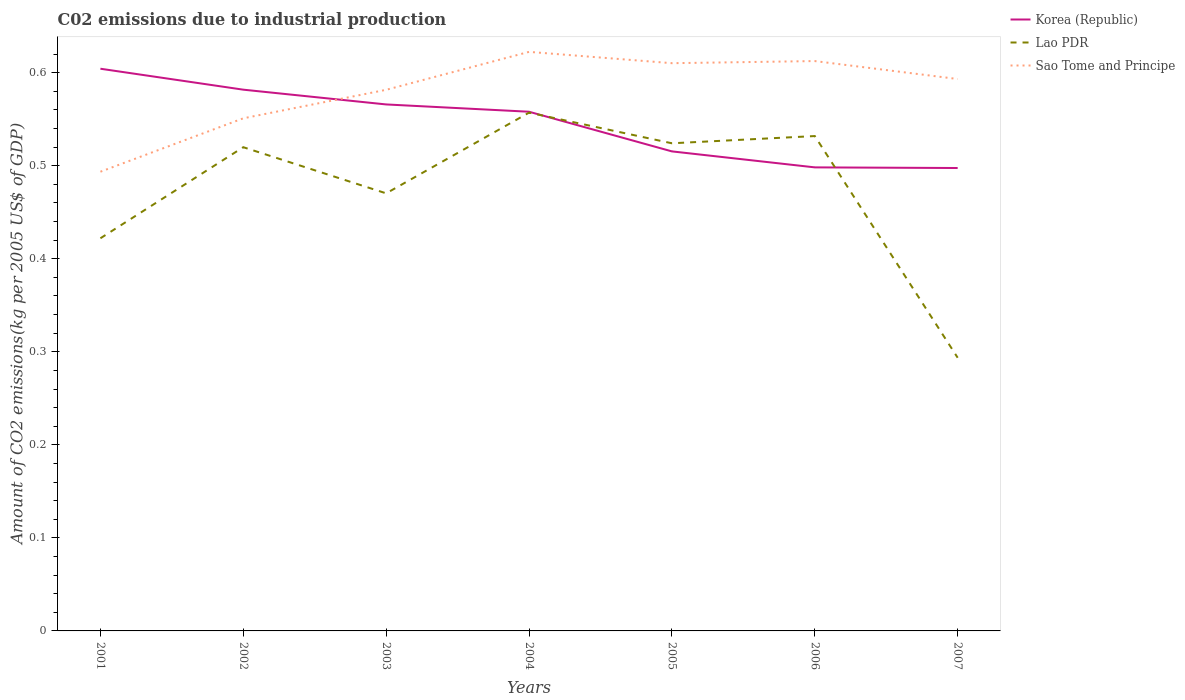Does the line corresponding to Korea (Republic) intersect with the line corresponding to Sao Tome and Principe?
Your response must be concise. Yes. Is the number of lines equal to the number of legend labels?
Keep it short and to the point. Yes. Across all years, what is the maximum amount of CO2 emitted due to industrial production in Sao Tome and Principe?
Keep it short and to the point. 0.49. What is the total amount of CO2 emitted due to industrial production in Korea (Republic) in the graph?
Provide a succinct answer. 0.07. What is the difference between the highest and the second highest amount of CO2 emitted due to industrial production in Korea (Republic)?
Your answer should be compact. 0.11. What is the difference between the highest and the lowest amount of CO2 emitted due to industrial production in Sao Tome and Principe?
Your answer should be compact. 5. Is the amount of CO2 emitted due to industrial production in Korea (Republic) strictly greater than the amount of CO2 emitted due to industrial production in Lao PDR over the years?
Keep it short and to the point. No. How many lines are there?
Offer a very short reply. 3. How many years are there in the graph?
Offer a very short reply. 7. How are the legend labels stacked?
Provide a succinct answer. Vertical. What is the title of the graph?
Provide a succinct answer. C02 emissions due to industrial production. Does "Northern Mariana Islands" appear as one of the legend labels in the graph?
Offer a very short reply. No. What is the label or title of the Y-axis?
Provide a short and direct response. Amount of CO2 emissions(kg per 2005 US$ of GDP). What is the Amount of CO2 emissions(kg per 2005 US$ of GDP) in Korea (Republic) in 2001?
Provide a succinct answer. 0.6. What is the Amount of CO2 emissions(kg per 2005 US$ of GDP) in Lao PDR in 2001?
Your answer should be compact. 0.42. What is the Amount of CO2 emissions(kg per 2005 US$ of GDP) of Sao Tome and Principe in 2001?
Your answer should be compact. 0.49. What is the Amount of CO2 emissions(kg per 2005 US$ of GDP) of Korea (Republic) in 2002?
Keep it short and to the point. 0.58. What is the Amount of CO2 emissions(kg per 2005 US$ of GDP) of Lao PDR in 2002?
Your answer should be compact. 0.52. What is the Amount of CO2 emissions(kg per 2005 US$ of GDP) in Sao Tome and Principe in 2002?
Keep it short and to the point. 0.55. What is the Amount of CO2 emissions(kg per 2005 US$ of GDP) in Korea (Republic) in 2003?
Provide a succinct answer. 0.57. What is the Amount of CO2 emissions(kg per 2005 US$ of GDP) in Lao PDR in 2003?
Provide a short and direct response. 0.47. What is the Amount of CO2 emissions(kg per 2005 US$ of GDP) of Sao Tome and Principe in 2003?
Give a very brief answer. 0.58. What is the Amount of CO2 emissions(kg per 2005 US$ of GDP) of Korea (Republic) in 2004?
Your response must be concise. 0.56. What is the Amount of CO2 emissions(kg per 2005 US$ of GDP) in Lao PDR in 2004?
Your answer should be very brief. 0.56. What is the Amount of CO2 emissions(kg per 2005 US$ of GDP) of Sao Tome and Principe in 2004?
Provide a short and direct response. 0.62. What is the Amount of CO2 emissions(kg per 2005 US$ of GDP) of Korea (Republic) in 2005?
Your answer should be very brief. 0.52. What is the Amount of CO2 emissions(kg per 2005 US$ of GDP) of Lao PDR in 2005?
Ensure brevity in your answer.  0.52. What is the Amount of CO2 emissions(kg per 2005 US$ of GDP) in Sao Tome and Principe in 2005?
Your answer should be compact. 0.61. What is the Amount of CO2 emissions(kg per 2005 US$ of GDP) of Korea (Republic) in 2006?
Your answer should be very brief. 0.5. What is the Amount of CO2 emissions(kg per 2005 US$ of GDP) of Lao PDR in 2006?
Offer a very short reply. 0.53. What is the Amount of CO2 emissions(kg per 2005 US$ of GDP) in Sao Tome and Principe in 2006?
Keep it short and to the point. 0.61. What is the Amount of CO2 emissions(kg per 2005 US$ of GDP) of Korea (Republic) in 2007?
Provide a succinct answer. 0.5. What is the Amount of CO2 emissions(kg per 2005 US$ of GDP) in Lao PDR in 2007?
Offer a terse response. 0.29. What is the Amount of CO2 emissions(kg per 2005 US$ of GDP) of Sao Tome and Principe in 2007?
Your answer should be compact. 0.59. Across all years, what is the maximum Amount of CO2 emissions(kg per 2005 US$ of GDP) in Korea (Republic)?
Offer a terse response. 0.6. Across all years, what is the maximum Amount of CO2 emissions(kg per 2005 US$ of GDP) in Lao PDR?
Offer a terse response. 0.56. Across all years, what is the maximum Amount of CO2 emissions(kg per 2005 US$ of GDP) in Sao Tome and Principe?
Your answer should be very brief. 0.62. Across all years, what is the minimum Amount of CO2 emissions(kg per 2005 US$ of GDP) in Korea (Republic)?
Provide a succinct answer. 0.5. Across all years, what is the minimum Amount of CO2 emissions(kg per 2005 US$ of GDP) in Lao PDR?
Give a very brief answer. 0.29. Across all years, what is the minimum Amount of CO2 emissions(kg per 2005 US$ of GDP) in Sao Tome and Principe?
Your answer should be compact. 0.49. What is the total Amount of CO2 emissions(kg per 2005 US$ of GDP) in Korea (Republic) in the graph?
Keep it short and to the point. 3.82. What is the total Amount of CO2 emissions(kg per 2005 US$ of GDP) in Lao PDR in the graph?
Keep it short and to the point. 3.32. What is the total Amount of CO2 emissions(kg per 2005 US$ of GDP) in Sao Tome and Principe in the graph?
Give a very brief answer. 4.06. What is the difference between the Amount of CO2 emissions(kg per 2005 US$ of GDP) of Korea (Republic) in 2001 and that in 2002?
Your answer should be compact. 0.02. What is the difference between the Amount of CO2 emissions(kg per 2005 US$ of GDP) in Lao PDR in 2001 and that in 2002?
Your answer should be compact. -0.1. What is the difference between the Amount of CO2 emissions(kg per 2005 US$ of GDP) in Sao Tome and Principe in 2001 and that in 2002?
Keep it short and to the point. -0.06. What is the difference between the Amount of CO2 emissions(kg per 2005 US$ of GDP) of Korea (Republic) in 2001 and that in 2003?
Your answer should be compact. 0.04. What is the difference between the Amount of CO2 emissions(kg per 2005 US$ of GDP) in Lao PDR in 2001 and that in 2003?
Provide a short and direct response. -0.05. What is the difference between the Amount of CO2 emissions(kg per 2005 US$ of GDP) of Sao Tome and Principe in 2001 and that in 2003?
Give a very brief answer. -0.09. What is the difference between the Amount of CO2 emissions(kg per 2005 US$ of GDP) of Korea (Republic) in 2001 and that in 2004?
Make the answer very short. 0.05. What is the difference between the Amount of CO2 emissions(kg per 2005 US$ of GDP) of Lao PDR in 2001 and that in 2004?
Offer a terse response. -0.14. What is the difference between the Amount of CO2 emissions(kg per 2005 US$ of GDP) of Sao Tome and Principe in 2001 and that in 2004?
Offer a terse response. -0.13. What is the difference between the Amount of CO2 emissions(kg per 2005 US$ of GDP) of Korea (Republic) in 2001 and that in 2005?
Make the answer very short. 0.09. What is the difference between the Amount of CO2 emissions(kg per 2005 US$ of GDP) of Lao PDR in 2001 and that in 2005?
Provide a short and direct response. -0.1. What is the difference between the Amount of CO2 emissions(kg per 2005 US$ of GDP) of Sao Tome and Principe in 2001 and that in 2005?
Offer a very short reply. -0.12. What is the difference between the Amount of CO2 emissions(kg per 2005 US$ of GDP) in Korea (Republic) in 2001 and that in 2006?
Offer a very short reply. 0.11. What is the difference between the Amount of CO2 emissions(kg per 2005 US$ of GDP) in Lao PDR in 2001 and that in 2006?
Give a very brief answer. -0.11. What is the difference between the Amount of CO2 emissions(kg per 2005 US$ of GDP) of Sao Tome and Principe in 2001 and that in 2006?
Keep it short and to the point. -0.12. What is the difference between the Amount of CO2 emissions(kg per 2005 US$ of GDP) of Korea (Republic) in 2001 and that in 2007?
Keep it short and to the point. 0.11. What is the difference between the Amount of CO2 emissions(kg per 2005 US$ of GDP) of Lao PDR in 2001 and that in 2007?
Offer a terse response. 0.13. What is the difference between the Amount of CO2 emissions(kg per 2005 US$ of GDP) in Sao Tome and Principe in 2001 and that in 2007?
Give a very brief answer. -0.1. What is the difference between the Amount of CO2 emissions(kg per 2005 US$ of GDP) in Korea (Republic) in 2002 and that in 2003?
Your answer should be compact. 0.02. What is the difference between the Amount of CO2 emissions(kg per 2005 US$ of GDP) in Lao PDR in 2002 and that in 2003?
Offer a terse response. 0.05. What is the difference between the Amount of CO2 emissions(kg per 2005 US$ of GDP) in Sao Tome and Principe in 2002 and that in 2003?
Ensure brevity in your answer.  -0.03. What is the difference between the Amount of CO2 emissions(kg per 2005 US$ of GDP) in Korea (Republic) in 2002 and that in 2004?
Your answer should be very brief. 0.02. What is the difference between the Amount of CO2 emissions(kg per 2005 US$ of GDP) in Lao PDR in 2002 and that in 2004?
Your response must be concise. -0.04. What is the difference between the Amount of CO2 emissions(kg per 2005 US$ of GDP) of Sao Tome and Principe in 2002 and that in 2004?
Your answer should be compact. -0.07. What is the difference between the Amount of CO2 emissions(kg per 2005 US$ of GDP) of Korea (Republic) in 2002 and that in 2005?
Ensure brevity in your answer.  0.07. What is the difference between the Amount of CO2 emissions(kg per 2005 US$ of GDP) of Lao PDR in 2002 and that in 2005?
Keep it short and to the point. -0. What is the difference between the Amount of CO2 emissions(kg per 2005 US$ of GDP) of Sao Tome and Principe in 2002 and that in 2005?
Provide a short and direct response. -0.06. What is the difference between the Amount of CO2 emissions(kg per 2005 US$ of GDP) of Korea (Republic) in 2002 and that in 2006?
Offer a very short reply. 0.08. What is the difference between the Amount of CO2 emissions(kg per 2005 US$ of GDP) of Lao PDR in 2002 and that in 2006?
Your answer should be compact. -0.01. What is the difference between the Amount of CO2 emissions(kg per 2005 US$ of GDP) in Sao Tome and Principe in 2002 and that in 2006?
Give a very brief answer. -0.06. What is the difference between the Amount of CO2 emissions(kg per 2005 US$ of GDP) in Korea (Republic) in 2002 and that in 2007?
Provide a short and direct response. 0.08. What is the difference between the Amount of CO2 emissions(kg per 2005 US$ of GDP) in Lao PDR in 2002 and that in 2007?
Provide a succinct answer. 0.23. What is the difference between the Amount of CO2 emissions(kg per 2005 US$ of GDP) in Sao Tome and Principe in 2002 and that in 2007?
Keep it short and to the point. -0.04. What is the difference between the Amount of CO2 emissions(kg per 2005 US$ of GDP) in Korea (Republic) in 2003 and that in 2004?
Provide a succinct answer. 0.01. What is the difference between the Amount of CO2 emissions(kg per 2005 US$ of GDP) in Lao PDR in 2003 and that in 2004?
Your answer should be very brief. -0.09. What is the difference between the Amount of CO2 emissions(kg per 2005 US$ of GDP) of Sao Tome and Principe in 2003 and that in 2004?
Offer a very short reply. -0.04. What is the difference between the Amount of CO2 emissions(kg per 2005 US$ of GDP) in Korea (Republic) in 2003 and that in 2005?
Your answer should be very brief. 0.05. What is the difference between the Amount of CO2 emissions(kg per 2005 US$ of GDP) of Lao PDR in 2003 and that in 2005?
Give a very brief answer. -0.05. What is the difference between the Amount of CO2 emissions(kg per 2005 US$ of GDP) of Sao Tome and Principe in 2003 and that in 2005?
Provide a short and direct response. -0.03. What is the difference between the Amount of CO2 emissions(kg per 2005 US$ of GDP) of Korea (Republic) in 2003 and that in 2006?
Ensure brevity in your answer.  0.07. What is the difference between the Amount of CO2 emissions(kg per 2005 US$ of GDP) of Lao PDR in 2003 and that in 2006?
Keep it short and to the point. -0.06. What is the difference between the Amount of CO2 emissions(kg per 2005 US$ of GDP) of Sao Tome and Principe in 2003 and that in 2006?
Keep it short and to the point. -0.03. What is the difference between the Amount of CO2 emissions(kg per 2005 US$ of GDP) in Korea (Republic) in 2003 and that in 2007?
Provide a short and direct response. 0.07. What is the difference between the Amount of CO2 emissions(kg per 2005 US$ of GDP) in Lao PDR in 2003 and that in 2007?
Offer a very short reply. 0.18. What is the difference between the Amount of CO2 emissions(kg per 2005 US$ of GDP) in Sao Tome and Principe in 2003 and that in 2007?
Give a very brief answer. -0.01. What is the difference between the Amount of CO2 emissions(kg per 2005 US$ of GDP) in Korea (Republic) in 2004 and that in 2005?
Your response must be concise. 0.04. What is the difference between the Amount of CO2 emissions(kg per 2005 US$ of GDP) of Lao PDR in 2004 and that in 2005?
Ensure brevity in your answer.  0.03. What is the difference between the Amount of CO2 emissions(kg per 2005 US$ of GDP) of Sao Tome and Principe in 2004 and that in 2005?
Give a very brief answer. 0.01. What is the difference between the Amount of CO2 emissions(kg per 2005 US$ of GDP) of Korea (Republic) in 2004 and that in 2006?
Offer a terse response. 0.06. What is the difference between the Amount of CO2 emissions(kg per 2005 US$ of GDP) of Lao PDR in 2004 and that in 2006?
Your answer should be very brief. 0.03. What is the difference between the Amount of CO2 emissions(kg per 2005 US$ of GDP) in Sao Tome and Principe in 2004 and that in 2006?
Offer a terse response. 0.01. What is the difference between the Amount of CO2 emissions(kg per 2005 US$ of GDP) of Korea (Republic) in 2004 and that in 2007?
Provide a short and direct response. 0.06. What is the difference between the Amount of CO2 emissions(kg per 2005 US$ of GDP) in Lao PDR in 2004 and that in 2007?
Offer a very short reply. 0.26. What is the difference between the Amount of CO2 emissions(kg per 2005 US$ of GDP) in Sao Tome and Principe in 2004 and that in 2007?
Keep it short and to the point. 0.03. What is the difference between the Amount of CO2 emissions(kg per 2005 US$ of GDP) of Korea (Republic) in 2005 and that in 2006?
Make the answer very short. 0.02. What is the difference between the Amount of CO2 emissions(kg per 2005 US$ of GDP) of Lao PDR in 2005 and that in 2006?
Your response must be concise. -0.01. What is the difference between the Amount of CO2 emissions(kg per 2005 US$ of GDP) in Sao Tome and Principe in 2005 and that in 2006?
Make the answer very short. -0. What is the difference between the Amount of CO2 emissions(kg per 2005 US$ of GDP) in Korea (Republic) in 2005 and that in 2007?
Ensure brevity in your answer.  0.02. What is the difference between the Amount of CO2 emissions(kg per 2005 US$ of GDP) in Lao PDR in 2005 and that in 2007?
Offer a very short reply. 0.23. What is the difference between the Amount of CO2 emissions(kg per 2005 US$ of GDP) in Sao Tome and Principe in 2005 and that in 2007?
Your answer should be very brief. 0.02. What is the difference between the Amount of CO2 emissions(kg per 2005 US$ of GDP) in Korea (Republic) in 2006 and that in 2007?
Your answer should be very brief. 0. What is the difference between the Amount of CO2 emissions(kg per 2005 US$ of GDP) in Lao PDR in 2006 and that in 2007?
Your response must be concise. 0.24. What is the difference between the Amount of CO2 emissions(kg per 2005 US$ of GDP) of Sao Tome and Principe in 2006 and that in 2007?
Your response must be concise. 0.02. What is the difference between the Amount of CO2 emissions(kg per 2005 US$ of GDP) of Korea (Republic) in 2001 and the Amount of CO2 emissions(kg per 2005 US$ of GDP) of Lao PDR in 2002?
Make the answer very short. 0.08. What is the difference between the Amount of CO2 emissions(kg per 2005 US$ of GDP) of Korea (Republic) in 2001 and the Amount of CO2 emissions(kg per 2005 US$ of GDP) of Sao Tome and Principe in 2002?
Ensure brevity in your answer.  0.05. What is the difference between the Amount of CO2 emissions(kg per 2005 US$ of GDP) in Lao PDR in 2001 and the Amount of CO2 emissions(kg per 2005 US$ of GDP) in Sao Tome and Principe in 2002?
Provide a short and direct response. -0.13. What is the difference between the Amount of CO2 emissions(kg per 2005 US$ of GDP) of Korea (Republic) in 2001 and the Amount of CO2 emissions(kg per 2005 US$ of GDP) of Lao PDR in 2003?
Provide a succinct answer. 0.13. What is the difference between the Amount of CO2 emissions(kg per 2005 US$ of GDP) of Korea (Republic) in 2001 and the Amount of CO2 emissions(kg per 2005 US$ of GDP) of Sao Tome and Principe in 2003?
Your answer should be very brief. 0.02. What is the difference between the Amount of CO2 emissions(kg per 2005 US$ of GDP) in Lao PDR in 2001 and the Amount of CO2 emissions(kg per 2005 US$ of GDP) in Sao Tome and Principe in 2003?
Give a very brief answer. -0.16. What is the difference between the Amount of CO2 emissions(kg per 2005 US$ of GDP) in Korea (Republic) in 2001 and the Amount of CO2 emissions(kg per 2005 US$ of GDP) in Lao PDR in 2004?
Give a very brief answer. 0.05. What is the difference between the Amount of CO2 emissions(kg per 2005 US$ of GDP) in Korea (Republic) in 2001 and the Amount of CO2 emissions(kg per 2005 US$ of GDP) in Sao Tome and Principe in 2004?
Your response must be concise. -0.02. What is the difference between the Amount of CO2 emissions(kg per 2005 US$ of GDP) of Lao PDR in 2001 and the Amount of CO2 emissions(kg per 2005 US$ of GDP) of Sao Tome and Principe in 2004?
Your answer should be very brief. -0.2. What is the difference between the Amount of CO2 emissions(kg per 2005 US$ of GDP) of Korea (Republic) in 2001 and the Amount of CO2 emissions(kg per 2005 US$ of GDP) of Lao PDR in 2005?
Your response must be concise. 0.08. What is the difference between the Amount of CO2 emissions(kg per 2005 US$ of GDP) in Korea (Republic) in 2001 and the Amount of CO2 emissions(kg per 2005 US$ of GDP) in Sao Tome and Principe in 2005?
Keep it short and to the point. -0.01. What is the difference between the Amount of CO2 emissions(kg per 2005 US$ of GDP) in Lao PDR in 2001 and the Amount of CO2 emissions(kg per 2005 US$ of GDP) in Sao Tome and Principe in 2005?
Give a very brief answer. -0.19. What is the difference between the Amount of CO2 emissions(kg per 2005 US$ of GDP) of Korea (Republic) in 2001 and the Amount of CO2 emissions(kg per 2005 US$ of GDP) of Lao PDR in 2006?
Give a very brief answer. 0.07. What is the difference between the Amount of CO2 emissions(kg per 2005 US$ of GDP) of Korea (Republic) in 2001 and the Amount of CO2 emissions(kg per 2005 US$ of GDP) of Sao Tome and Principe in 2006?
Offer a very short reply. -0.01. What is the difference between the Amount of CO2 emissions(kg per 2005 US$ of GDP) in Lao PDR in 2001 and the Amount of CO2 emissions(kg per 2005 US$ of GDP) in Sao Tome and Principe in 2006?
Your answer should be compact. -0.19. What is the difference between the Amount of CO2 emissions(kg per 2005 US$ of GDP) in Korea (Republic) in 2001 and the Amount of CO2 emissions(kg per 2005 US$ of GDP) in Lao PDR in 2007?
Give a very brief answer. 0.31. What is the difference between the Amount of CO2 emissions(kg per 2005 US$ of GDP) in Korea (Republic) in 2001 and the Amount of CO2 emissions(kg per 2005 US$ of GDP) in Sao Tome and Principe in 2007?
Ensure brevity in your answer.  0.01. What is the difference between the Amount of CO2 emissions(kg per 2005 US$ of GDP) of Lao PDR in 2001 and the Amount of CO2 emissions(kg per 2005 US$ of GDP) of Sao Tome and Principe in 2007?
Keep it short and to the point. -0.17. What is the difference between the Amount of CO2 emissions(kg per 2005 US$ of GDP) in Korea (Republic) in 2002 and the Amount of CO2 emissions(kg per 2005 US$ of GDP) in Lao PDR in 2003?
Offer a terse response. 0.11. What is the difference between the Amount of CO2 emissions(kg per 2005 US$ of GDP) of Korea (Republic) in 2002 and the Amount of CO2 emissions(kg per 2005 US$ of GDP) of Sao Tome and Principe in 2003?
Your answer should be compact. 0. What is the difference between the Amount of CO2 emissions(kg per 2005 US$ of GDP) in Lao PDR in 2002 and the Amount of CO2 emissions(kg per 2005 US$ of GDP) in Sao Tome and Principe in 2003?
Keep it short and to the point. -0.06. What is the difference between the Amount of CO2 emissions(kg per 2005 US$ of GDP) in Korea (Republic) in 2002 and the Amount of CO2 emissions(kg per 2005 US$ of GDP) in Lao PDR in 2004?
Offer a terse response. 0.02. What is the difference between the Amount of CO2 emissions(kg per 2005 US$ of GDP) in Korea (Republic) in 2002 and the Amount of CO2 emissions(kg per 2005 US$ of GDP) in Sao Tome and Principe in 2004?
Ensure brevity in your answer.  -0.04. What is the difference between the Amount of CO2 emissions(kg per 2005 US$ of GDP) of Lao PDR in 2002 and the Amount of CO2 emissions(kg per 2005 US$ of GDP) of Sao Tome and Principe in 2004?
Give a very brief answer. -0.1. What is the difference between the Amount of CO2 emissions(kg per 2005 US$ of GDP) in Korea (Republic) in 2002 and the Amount of CO2 emissions(kg per 2005 US$ of GDP) in Lao PDR in 2005?
Make the answer very short. 0.06. What is the difference between the Amount of CO2 emissions(kg per 2005 US$ of GDP) in Korea (Republic) in 2002 and the Amount of CO2 emissions(kg per 2005 US$ of GDP) in Sao Tome and Principe in 2005?
Offer a very short reply. -0.03. What is the difference between the Amount of CO2 emissions(kg per 2005 US$ of GDP) in Lao PDR in 2002 and the Amount of CO2 emissions(kg per 2005 US$ of GDP) in Sao Tome and Principe in 2005?
Provide a short and direct response. -0.09. What is the difference between the Amount of CO2 emissions(kg per 2005 US$ of GDP) of Korea (Republic) in 2002 and the Amount of CO2 emissions(kg per 2005 US$ of GDP) of Lao PDR in 2006?
Provide a succinct answer. 0.05. What is the difference between the Amount of CO2 emissions(kg per 2005 US$ of GDP) of Korea (Republic) in 2002 and the Amount of CO2 emissions(kg per 2005 US$ of GDP) of Sao Tome and Principe in 2006?
Ensure brevity in your answer.  -0.03. What is the difference between the Amount of CO2 emissions(kg per 2005 US$ of GDP) of Lao PDR in 2002 and the Amount of CO2 emissions(kg per 2005 US$ of GDP) of Sao Tome and Principe in 2006?
Offer a very short reply. -0.09. What is the difference between the Amount of CO2 emissions(kg per 2005 US$ of GDP) in Korea (Republic) in 2002 and the Amount of CO2 emissions(kg per 2005 US$ of GDP) in Lao PDR in 2007?
Provide a succinct answer. 0.29. What is the difference between the Amount of CO2 emissions(kg per 2005 US$ of GDP) in Korea (Republic) in 2002 and the Amount of CO2 emissions(kg per 2005 US$ of GDP) in Sao Tome and Principe in 2007?
Keep it short and to the point. -0.01. What is the difference between the Amount of CO2 emissions(kg per 2005 US$ of GDP) in Lao PDR in 2002 and the Amount of CO2 emissions(kg per 2005 US$ of GDP) in Sao Tome and Principe in 2007?
Your response must be concise. -0.07. What is the difference between the Amount of CO2 emissions(kg per 2005 US$ of GDP) of Korea (Republic) in 2003 and the Amount of CO2 emissions(kg per 2005 US$ of GDP) of Lao PDR in 2004?
Offer a very short reply. 0.01. What is the difference between the Amount of CO2 emissions(kg per 2005 US$ of GDP) of Korea (Republic) in 2003 and the Amount of CO2 emissions(kg per 2005 US$ of GDP) of Sao Tome and Principe in 2004?
Offer a terse response. -0.06. What is the difference between the Amount of CO2 emissions(kg per 2005 US$ of GDP) of Lao PDR in 2003 and the Amount of CO2 emissions(kg per 2005 US$ of GDP) of Sao Tome and Principe in 2004?
Provide a short and direct response. -0.15. What is the difference between the Amount of CO2 emissions(kg per 2005 US$ of GDP) in Korea (Republic) in 2003 and the Amount of CO2 emissions(kg per 2005 US$ of GDP) in Lao PDR in 2005?
Make the answer very short. 0.04. What is the difference between the Amount of CO2 emissions(kg per 2005 US$ of GDP) of Korea (Republic) in 2003 and the Amount of CO2 emissions(kg per 2005 US$ of GDP) of Sao Tome and Principe in 2005?
Offer a very short reply. -0.04. What is the difference between the Amount of CO2 emissions(kg per 2005 US$ of GDP) in Lao PDR in 2003 and the Amount of CO2 emissions(kg per 2005 US$ of GDP) in Sao Tome and Principe in 2005?
Provide a short and direct response. -0.14. What is the difference between the Amount of CO2 emissions(kg per 2005 US$ of GDP) of Korea (Republic) in 2003 and the Amount of CO2 emissions(kg per 2005 US$ of GDP) of Lao PDR in 2006?
Keep it short and to the point. 0.03. What is the difference between the Amount of CO2 emissions(kg per 2005 US$ of GDP) in Korea (Republic) in 2003 and the Amount of CO2 emissions(kg per 2005 US$ of GDP) in Sao Tome and Principe in 2006?
Offer a terse response. -0.05. What is the difference between the Amount of CO2 emissions(kg per 2005 US$ of GDP) in Lao PDR in 2003 and the Amount of CO2 emissions(kg per 2005 US$ of GDP) in Sao Tome and Principe in 2006?
Your answer should be compact. -0.14. What is the difference between the Amount of CO2 emissions(kg per 2005 US$ of GDP) of Korea (Republic) in 2003 and the Amount of CO2 emissions(kg per 2005 US$ of GDP) of Lao PDR in 2007?
Your answer should be compact. 0.27. What is the difference between the Amount of CO2 emissions(kg per 2005 US$ of GDP) of Korea (Republic) in 2003 and the Amount of CO2 emissions(kg per 2005 US$ of GDP) of Sao Tome and Principe in 2007?
Your answer should be compact. -0.03. What is the difference between the Amount of CO2 emissions(kg per 2005 US$ of GDP) in Lao PDR in 2003 and the Amount of CO2 emissions(kg per 2005 US$ of GDP) in Sao Tome and Principe in 2007?
Make the answer very short. -0.12. What is the difference between the Amount of CO2 emissions(kg per 2005 US$ of GDP) of Korea (Republic) in 2004 and the Amount of CO2 emissions(kg per 2005 US$ of GDP) of Lao PDR in 2005?
Make the answer very short. 0.03. What is the difference between the Amount of CO2 emissions(kg per 2005 US$ of GDP) in Korea (Republic) in 2004 and the Amount of CO2 emissions(kg per 2005 US$ of GDP) in Sao Tome and Principe in 2005?
Ensure brevity in your answer.  -0.05. What is the difference between the Amount of CO2 emissions(kg per 2005 US$ of GDP) of Lao PDR in 2004 and the Amount of CO2 emissions(kg per 2005 US$ of GDP) of Sao Tome and Principe in 2005?
Provide a short and direct response. -0.05. What is the difference between the Amount of CO2 emissions(kg per 2005 US$ of GDP) in Korea (Republic) in 2004 and the Amount of CO2 emissions(kg per 2005 US$ of GDP) in Lao PDR in 2006?
Ensure brevity in your answer.  0.03. What is the difference between the Amount of CO2 emissions(kg per 2005 US$ of GDP) of Korea (Republic) in 2004 and the Amount of CO2 emissions(kg per 2005 US$ of GDP) of Sao Tome and Principe in 2006?
Offer a very short reply. -0.05. What is the difference between the Amount of CO2 emissions(kg per 2005 US$ of GDP) of Lao PDR in 2004 and the Amount of CO2 emissions(kg per 2005 US$ of GDP) of Sao Tome and Principe in 2006?
Provide a short and direct response. -0.06. What is the difference between the Amount of CO2 emissions(kg per 2005 US$ of GDP) in Korea (Republic) in 2004 and the Amount of CO2 emissions(kg per 2005 US$ of GDP) in Lao PDR in 2007?
Your response must be concise. 0.26. What is the difference between the Amount of CO2 emissions(kg per 2005 US$ of GDP) of Korea (Republic) in 2004 and the Amount of CO2 emissions(kg per 2005 US$ of GDP) of Sao Tome and Principe in 2007?
Your answer should be compact. -0.04. What is the difference between the Amount of CO2 emissions(kg per 2005 US$ of GDP) of Lao PDR in 2004 and the Amount of CO2 emissions(kg per 2005 US$ of GDP) of Sao Tome and Principe in 2007?
Give a very brief answer. -0.04. What is the difference between the Amount of CO2 emissions(kg per 2005 US$ of GDP) of Korea (Republic) in 2005 and the Amount of CO2 emissions(kg per 2005 US$ of GDP) of Lao PDR in 2006?
Keep it short and to the point. -0.02. What is the difference between the Amount of CO2 emissions(kg per 2005 US$ of GDP) of Korea (Republic) in 2005 and the Amount of CO2 emissions(kg per 2005 US$ of GDP) of Sao Tome and Principe in 2006?
Provide a short and direct response. -0.1. What is the difference between the Amount of CO2 emissions(kg per 2005 US$ of GDP) in Lao PDR in 2005 and the Amount of CO2 emissions(kg per 2005 US$ of GDP) in Sao Tome and Principe in 2006?
Ensure brevity in your answer.  -0.09. What is the difference between the Amount of CO2 emissions(kg per 2005 US$ of GDP) in Korea (Republic) in 2005 and the Amount of CO2 emissions(kg per 2005 US$ of GDP) in Lao PDR in 2007?
Offer a terse response. 0.22. What is the difference between the Amount of CO2 emissions(kg per 2005 US$ of GDP) in Korea (Republic) in 2005 and the Amount of CO2 emissions(kg per 2005 US$ of GDP) in Sao Tome and Principe in 2007?
Ensure brevity in your answer.  -0.08. What is the difference between the Amount of CO2 emissions(kg per 2005 US$ of GDP) of Lao PDR in 2005 and the Amount of CO2 emissions(kg per 2005 US$ of GDP) of Sao Tome and Principe in 2007?
Offer a terse response. -0.07. What is the difference between the Amount of CO2 emissions(kg per 2005 US$ of GDP) in Korea (Republic) in 2006 and the Amount of CO2 emissions(kg per 2005 US$ of GDP) in Lao PDR in 2007?
Offer a very short reply. 0.2. What is the difference between the Amount of CO2 emissions(kg per 2005 US$ of GDP) of Korea (Republic) in 2006 and the Amount of CO2 emissions(kg per 2005 US$ of GDP) of Sao Tome and Principe in 2007?
Give a very brief answer. -0.1. What is the difference between the Amount of CO2 emissions(kg per 2005 US$ of GDP) in Lao PDR in 2006 and the Amount of CO2 emissions(kg per 2005 US$ of GDP) in Sao Tome and Principe in 2007?
Provide a succinct answer. -0.06. What is the average Amount of CO2 emissions(kg per 2005 US$ of GDP) in Korea (Republic) per year?
Keep it short and to the point. 0.55. What is the average Amount of CO2 emissions(kg per 2005 US$ of GDP) of Lao PDR per year?
Provide a succinct answer. 0.47. What is the average Amount of CO2 emissions(kg per 2005 US$ of GDP) of Sao Tome and Principe per year?
Ensure brevity in your answer.  0.58. In the year 2001, what is the difference between the Amount of CO2 emissions(kg per 2005 US$ of GDP) of Korea (Republic) and Amount of CO2 emissions(kg per 2005 US$ of GDP) of Lao PDR?
Offer a terse response. 0.18. In the year 2001, what is the difference between the Amount of CO2 emissions(kg per 2005 US$ of GDP) of Korea (Republic) and Amount of CO2 emissions(kg per 2005 US$ of GDP) of Sao Tome and Principe?
Your response must be concise. 0.11. In the year 2001, what is the difference between the Amount of CO2 emissions(kg per 2005 US$ of GDP) in Lao PDR and Amount of CO2 emissions(kg per 2005 US$ of GDP) in Sao Tome and Principe?
Ensure brevity in your answer.  -0.07. In the year 2002, what is the difference between the Amount of CO2 emissions(kg per 2005 US$ of GDP) of Korea (Republic) and Amount of CO2 emissions(kg per 2005 US$ of GDP) of Lao PDR?
Your response must be concise. 0.06. In the year 2002, what is the difference between the Amount of CO2 emissions(kg per 2005 US$ of GDP) of Korea (Republic) and Amount of CO2 emissions(kg per 2005 US$ of GDP) of Sao Tome and Principe?
Make the answer very short. 0.03. In the year 2002, what is the difference between the Amount of CO2 emissions(kg per 2005 US$ of GDP) of Lao PDR and Amount of CO2 emissions(kg per 2005 US$ of GDP) of Sao Tome and Principe?
Offer a terse response. -0.03. In the year 2003, what is the difference between the Amount of CO2 emissions(kg per 2005 US$ of GDP) of Korea (Republic) and Amount of CO2 emissions(kg per 2005 US$ of GDP) of Lao PDR?
Make the answer very short. 0.1. In the year 2003, what is the difference between the Amount of CO2 emissions(kg per 2005 US$ of GDP) of Korea (Republic) and Amount of CO2 emissions(kg per 2005 US$ of GDP) of Sao Tome and Principe?
Offer a terse response. -0.02. In the year 2003, what is the difference between the Amount of CO2 emissions(kg per 2005 US$ of GDP) in Lao PDR and Amount of CO2 emissions(kg per 2005 US$ of GDP) in Sao Tome and Principe?
Your answer should be very brief. -0.11. In the year 2004, what is the difference between the Amount of CO2 emissions(kg per 2005 US$ of GDP) in Korea (Republic) and Amount of CO2 emissions(kg per 2005 US$ of GDP) in Lao PDR?
Your answer should be very brief. 0. In the year 2004, what is the difference between the Amount of CO2 emissions(kg per 2005 US$ of GDP) in Korea (Republic) and Amount of CO2 emissions(kg per 2005 US$ of GDP) in Sao Tome and Principe?
Ensure brevity in your answer.  -0.06. In the year 2004, what is the difference between the Amount of CO2 emissions(kg per 2005 US$ of GDP) in Lao PDR and Amount of CO2 emissions(kg per 2005 US$ of GDP) in Sao Tome and Principe?
Offer a very short reply. -0.07. In the year 2005, what is the difference between the Amount of CO2 emissions(kg per 2005 US$ of GDP) of Korea (Republic) and Amount of CO2 emissions(kg per 2005 US$ of GDP) of Lao PDR?
Ensure brevity in your answer.  -0.01. In the year 2005, what is the difference between the Amount of CO2 emissions(kg per 2005 US$ of GDP) in Korea (Republic) and Amount of CO2 emissions(kg per 2005 US$ of GDP) in Sao Tome and Principe?
Keep it short and to the point. -0.09. In the year 2005, what is the difference between the Amount of CO2 emissions(kg per 2005 US$ of GDP) in Lao PDR and Amount of CO2 emissions(kg per 2005 US$ of GDP) in Sao Tome and Principe?
Provide a succinct answer. -0.09. In the year 2006, what is the difference between the Amount of CO2 emissions(kg per 2005 US$ of GDP) of Korea (Republic) and Amount of CO2 emissions(kg per 2005 US$ of GDP) of Lao PDR?
Provide a succinct answer. -0.03. In the year 2006, what is the difference between the Amount of CO2 emissions(kg per 2005 US$ of GDP) in Korea (Republic) and Amount of CO2 emissions(kg per 2005 US$ of GDP) in Sao Tome and Principe?
Provide a succinct answer. -0.11. In the year 2006, what is the difference between the Amount of CO2 emissions(kg per 2005 US$ of GDP) in Lao PDR and Amount of CO2 emissions(kg per 2005 US$ of GDP) in Sao Tome and Principe?
Your answer should be very brief. -0.08. In the year 2007, what is the difference between the Amount of CO2 emissions(kg per 2005 US$ of GDP) in Korea (Republic) and Amount of CO2 emissions(kg per 2005 US$ of GDP) in Lao PDR?
Make the answer very short. 0.2. In the year 2007, what is the difference between the Amount of CO2 emissions(kg per 2005 US$ of GDP) in Korea (Republic) and Amount of CO2 emissions(kg per 2005 US$ of GDP) in Sao Tome and Principe?
Keep it short and to the point. -0.1. In the year 2007, what is the difference between the Amount of CO2 emissions(kg per 2005 US$ of GDP) of Lao PDR and Amount of CO2 emissions(kg per 2005 US$ of GDP) of Sao Tome and Principe?
Give a very brief answer. -0.3. What is the ratio of the Amount of CO2 emissions(kg per 2005 US$ of GDP) in Korea (Republic) in 2001 to that in 2002?
Offer a terse response. 1.04. What is the ratio of the Amount of CO2 emissions(kg per 2005 US$ of GDP) in Lao PDR in 2001 to that in 2002?
Offer a very short reply. 0.81. What is the ratio of the Amount of CO2 emissions(kg per 2005 US$ of GDP) in Sao Tome and Principe in 2001 to that in 2002?
Make the answer very short. 0.9. What is the ratio of the Amount of CO2 emissions(kg per 2005 US$ of GDP) of Korea (Republic) in 2001 to that in 2003?
Offer a very short reply. 1.07. What is the ratio of the Amount of CO2 emissions(kg per 2005 US$ of GDP) of Lao PDR in 2001 to that in 2003?
Make the answer very short. 0.9. What is the ratio of the Amount of CO2 emissions(kg per 2005 US$ of GDP) in Sao Tome and Principe in 2001 to that in 2003?
Give a very brief answer. 0.85. What is the ratio of the Amount of CO2 emissions(kg per 2005 US$ of GDP) of Korea (Republic) in 2001 to that in 2004?
Keep it short and to the point. 1.08. What is the ratio of the Amount of CO2 emissions(kg per 2005 US$ of GDP) in Lao PDR in 2001 to that in 2004?
Give a very brief answer. 0.76. What is the ratio of the Amount of CO2 emissions(kg per 2005 US$ of GDP) in Sao Tome and Principe in 2001 to that in 2004?
Your answer should be compact. 0.79. What is the ratio of the Amount of CO2 emissions(kg per 2005 US$ of GDP) in Korea (Republic) in 2001 to that in 2005?
Give a very brief answer. 1.17. What is the ratio of the Amount of CO2 emissions(kg per 2005 US$ of GDP) in Lao PDR in 2001 to that in 2005?
Ensure brevity in your answer.  0.81. What is the ratio of the Amount of CO2 emissions(kg per 2005 US$ of GDP) of Sao Tome and Principe in 2001 to that in 2005?
Offer a very short reply. 0.81. What is the ratio of the Amount of CO2 emissions(kg per 2005 US$ of GDP) of Korea (Republic) in 2001 to that in 2006?
Your answer should be very brief. 1.21. What is the ratio of the Amount of CO2 emissions(kg per 2005 US$ of GDP) of Lao PDR in 2001 to that in 2006?
Offer a terse response. 0.79. What is the ratio of the Amount of CO2 emissions(kg per 2005 US$ of GDP) of Sao Tome and Principe in 2001 to that in 2006?
Provide a succinct answer. 0.81. What is the ratio of the Amount of CO2 emissions(kg per 2005 US$ of GDP) in Korea (Republic) in 2001 to that in 2007?
Provide a succinct answer. 1.21. What is the ratio of the Amount of CO2 emissions(kg per 2005 US$ of GDP) of Lao PDR in 2001 to that in 2007?
Provide a succinct answer. 1.44. What is the ratio of the Amount of CO2 emissions(kg per 2005 US$ of GDP) in Sao Tome and Principe in 2001 to that in 2007?
Offer a very short reply. 0.83. What is the ratio of the Amount of CO2 emissions(kg per 2005 US$ of GDP) of Korea (Republic) in 2002 to that in 2003?
Offer a terse response. 1.03. What is the ratio of the Amount of CO2 emissions(kg per 2005 US$ of GDP) of Lao PDR in 2002 to that in 2003?
Keep it short and to the point. 1.11. What is the ratio of the Amount of CO2 emissions(kg per 2005 US$ of GDP) of Sao Tome and Principe in 2002 to that in 2003?
Your answer should be compact. 0.95. What is the ratio of the Amount of CO2 emissions(kg per 2005 US$ of GDP) of Korea (Republic) in 2002 to that in 2004?
Ensure brevity in your answer.  1.04. What is the ratio of the Amount of CO2 emissions(kg per 2005 US$ of GDP) of Lao PDR in 2002 to that in 2004?
Your answer should be compact. 0.93. What is the ratio of the Amount of CO2 emissions(kg per 2005 US$ of GDP) in Sao Tome and Principe in 2002 to that in 2004?
Provide a succinct answer. 0.89. What is the ratio of the Amount of CO2 emissions(kg per 2005 US$ of GDP) of Korea (Republic) in 2002 to that in 2005?
Ensure brevity in your answer.  1.13. What is the ratio of the Amount of CO2 emissions(kg per 2005 US$ of GDP) in Lao PDR in 2002 to that in 2005?
Make the answer very short. 0.99. What is the ratio of the Amount of CO2 emissions(kg per 2005 US$ of GDP) in Sao Tome and Principe in 2002 to that in 2005?
Provide a succinct answer. 0.9. What is the ratio of the Amount of CO2 emissions(kg per 2005 US$ of GDP) in Korea (Republic) in 2002 to that in 2006?
Ensure brevity in your answer.  1.17. What is the ratio of the Amount of CO2 emissions(kg per 2005 US$ of GDP) in Lao PDR in 2002 to that in 2006?
Keep it short and to the point. 0.98. What is the ratio of the Amount of CO2 emissions(kg per 2005 US$ of GDP) in Sao Tome and Principe in 2002 to that in 2006?
Provide a succinct answer. 0.9. What is the ratio of the Amount of CO2 emissions(kg per 2005 US$ of GDP) of Korea (Republic) in 2002 to that in 2007?
Provide a short and direct response. 1.17. What is the ratio of the Amount of CO2 emissions(kg per 2005 US$ of GDP) of Lao PDR in 2002 to that in 2007?
Offer a terse response. 1.77. What is the ratio of the Amount of CO2 emissions(kg per 2005 US$ of GDP) in Sao Tome and Principe in 2002 to that in 2007?
Your answer should be very brief. 0.93. What is the ratio of the Amount of CO2 emissions(kg per 2005 US$ of GDP) in Korea (Republic) in 2003 to that in 2004?
Keep it short and to the point. 1.01. What is the ratio of the Amount of CO2 emissions(kg per 2005 US$ of GDP) in Lao PDR in 2003 to that in 2004?
Offer a very short reply. 0.84. What is the ratio of the Amount of CO2 emissions(kg per 2005 US$ of GDP) of Sao Tome and Principe in 2003 to that in 2004?
Offer a very short reply. 0.93. What is the ratio of the Amount of CO2 emissions(kg per 2005 US$ of GDP) in Korea (Republic) in 2003 to that in 2005?
Provide a short and direct response. 1.1. What is the ratio of the Amount of CO2 emissions(kg per 2005 US$ of GDP) in Lao PDR in 2003 to that in 2005?
Keep it short and to the point. 0.9. What is the ratio of the Amount of CO2 emissions(kg per 2005 US$ of GDP) of Sao Tome and Principe in 2003 to that in 2005?
Offer a terse response. 0.95. What is the ratio of the Amount of CO2 emissions(kg per 2005 US$ of GDP) in Korea (Republic) in 2003 to that in 2006?
Provide a succinct answer. 1.14. What is the ratio of the Amount of CO2 emissions(kg per 2005 US$ of GDP) of Lao PDR in 2003 to that in 2006?
Make the answer very short. 0.88. What is the ratio of the Amount of CO2 emissions(kg per 2005 US$ of GDP) of Sao Tome and Principe in 2003 to that in 2006?
Your answer should be compact. 0.95. What is the ratio of the Amount of CO2 emissions(kg per 2005 US$ of GDP) in Korea (Republic) in 2003 to that in 2007?
Your answer should be very brief. 1.14. What is the ratio of the Amount of CO2 emissions(kg per 2005 US$ of GDP) in Lao PDR in 2003 to that in 2007?
Give a very brief answer. 1.6. What is the ratio of the Amount of CO2 emissions(kg per 2005 US$ of GDP) in Sao Tome and Principe in 2003 to that in 2007?
Provide a short and direct response. 0.98. What is the ratio of the Amount of CO2 emissions(kg per 2005 US$ of GDP) of Korea (Republic) in 2004 to that in 2005?
Offer a terse response. 1.08. What is the ratio of the Amount of CO2 emissions(kg per 2005 US$ of GDP) in Lao PDR in 2004 to that in 2005?
Make the answer very short. 1.06. What is the ratio of the Amount of CO2 emissions(kg per 2005 US$ of GDP) in Sao Tome and Principe in 2004 to that in 2005?
Give a very brief answer. 1.02. What is the ratio of the Amount of CO2 emissions(kg per 2005 US$ of GDP) of Korea (Republic) in 2004 to that in 2006?
Keep it short and to the point. 1.12. What is the ratio of the Amount of CO2 emissions(kg per 2005 US$ of GDP) of Lao PDR in 2004 to that in 2006?
Make the answer very short. 1.05. What is the ratio of the Amount of CO2 emissions(kg per 2005 US$ of GDP) of Sao Tome and Principe in 2004 to that in 2006?
Your answer should be compact. 1.02. What is the ratio of the Amount of CO2 emissions(kg per 2005 US$ of GDP) of Korea (Republic) in 2004 to that in 2007?
Give a very brief answer. 1.12. What is the ratio of the Amount of CO2 emissions(kg per 2005 US$ of GDP) of Lao PDR in 2004 to that in 2007?
Ensure brevity in your answer.  1.9. What is the ratio of the Amount of CO2 emissions(kg per 2005 US$ of GDP) in Sao Tome and Principe in 2004 to that in 2007?
Give a very brief answer. 1.05. What is the ratio of the Amount of CO2 emissions(kg per 2005 US$ of GDP) of Korea (Republic) in 2005 to that in 2006?
Offer a very short reply. 1.03. What is the ratio of the Amount of CO2 emissions(kg per 2005 US$ of GDP) in Lao PDR in 2005 to that in 2006?
Make the answer very short. 0.99. What is the ratio of the Amount of CO2 emissions(kg per 2005 US$ of GDP) in Korea (Republic) in 2005 to that in 2007?
Your response must be concise. 1.04. What is the ratio of the Amount of CO2 emissions(kg per 2005 US$ of GDP) of Lao PDR in 2005 to that in 2007?
Keep it short and to the point. 1.78. What is the ratio of the Amount of CO2 emissions(kg per 2005 US$ of GDP) of Sao Tome and Principe in 2005 to that in 2007?
Provide a short and direct response. 1.03. What is the ratio of the Amount of CO2 emissions(kg per 2005 US$ of GDP) in Korea (Republic) in 2006 to that in 2007?
Make the answer very short. 1. What is the ratio of the Amount of CO2 emissions(kg per 2005 US$ of GDP) in Lao PDR in 2006 to that in 2007?
Give a very brief answer. 1.81. What is the ratio of the Amount of CO2 emissions(kg per 2005 US$ of GDP) of Sao Tome and Principe in 2006 to that in 2007?
Provide a succinct answer. 1.03. What is the difference between the highest and the second highest Amount of CO2 emissions(kg per 2005 US$ of GDP) of Korea (Republic)?
Make the answer very short. 0.02. What is the difference between the highest and the second highest Amount of CO2 emissions(kg per 2005 US$ of GDP) in Lao PDR?
Provide a succinct answer. 0.03. What is the difference between the highest and the second highest Amount of CO2 emissions(kg per 2005 US$ of GDP) in Sao Tome and Principe?
Provide a succinct answer. 0.01. What is the difference between the highest and the lowest Amount of CO2 emissions(kg per 2005 US$ of GDP) in Korea (Republic)?
Provide a succinct answer. 0.11. What is the difference between the highest and the lowest Amount of CO2 emissions(kg per 2005 US$ of GDP) in Lao PDR?
Keep it short and to the point. 0.26. What is the difference between the highest and the lowest Amount of CO2 emissions(kg per 2005 US$ of GDP) of Sao Tome and Principe?
Make the answer very short. 0.13. 